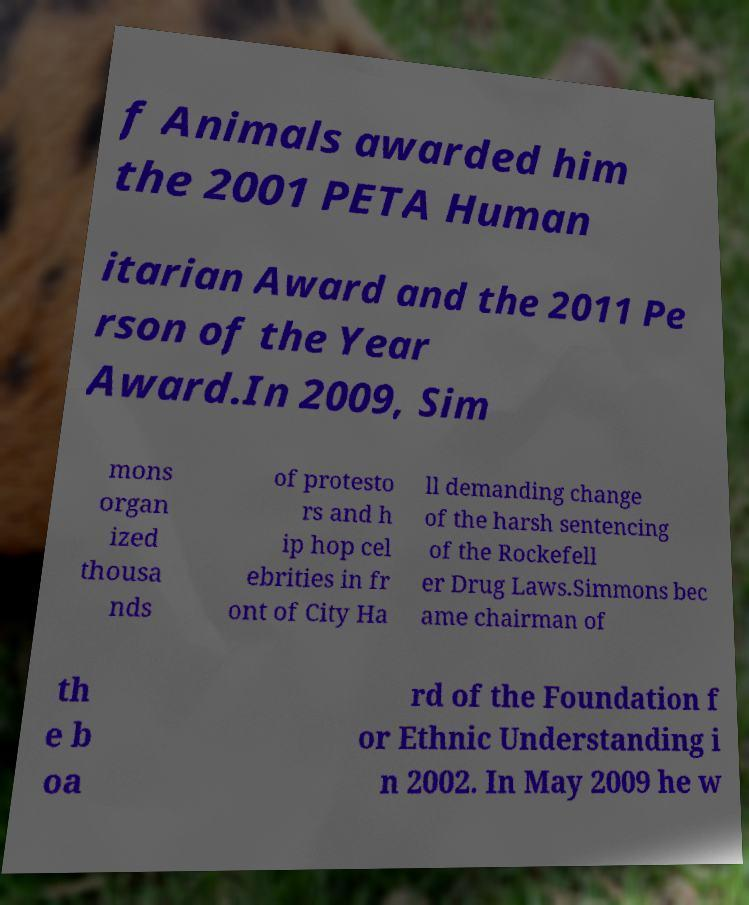Can you read and provide the text displayed in the image?This photo seems to have some interesting text. Can you extract and type it out for me? f Animals awarded him the 2001 PETA Human itarian Award and the 2011 Pe rson of the Year Award.In 2009, Sim mons organ ized thousa nds of protesto rs and h ip hop cel ebrities in fr ont of City Ha ll demanding change of the harsh sentencing of the Rockefell er Drug Laws.Simmons bec ame chairman of th e b oa rd of the Foundation f or Ethnic Understanding i n 2002. In May 2009 he w 